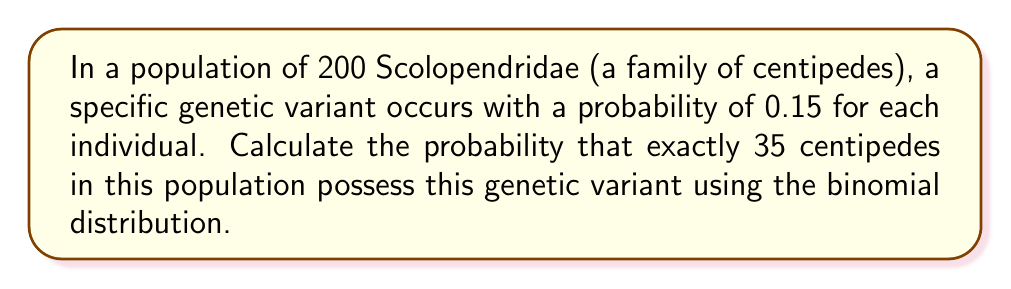Teach me how to tackle this problem. To solve this problem, we'll use the binomial distribution formula:

$$ P(X=k) = \binom{n}{k} p^k (1-p)^{n-k} $$

Where:
- $n$ is the total number of trials (population size)
- $k$ is the number of successes (centipedes with the genetic variant)
- $p$ is the probability of success for each trial

Given:
- $n = 200$ (population size)
- $k = 35$ (number of centipedes with the variant)
- $p = 0.15$ (probability of an individual having the variant)

Step 1: Calculate the binomial coefficient $\binom{n}{k}$
$$ \binom{200}{35} = \frac{200!}{35!(200-35)!} = \frac{200!}{35!165!} $$

Step 2: Calculate $p^k$
$$ 0.15^{35} $$

Step 3: Calculate $(1-p)^{n-k}$
$$ (1-0.15)^{200-35} = 0.85^{165} $$

Step 4: Multiply all components
$$ P(X=35) = \binom{200}{35} \cdot 0.15^{35} \cdot 0.85^{165} $$

Step 5: Evaluate the expression (using a calculator or computer)
$$ P(X=35) \approx 0.0399 $$
Answer: $0.0399$ or $3.99\%$ 